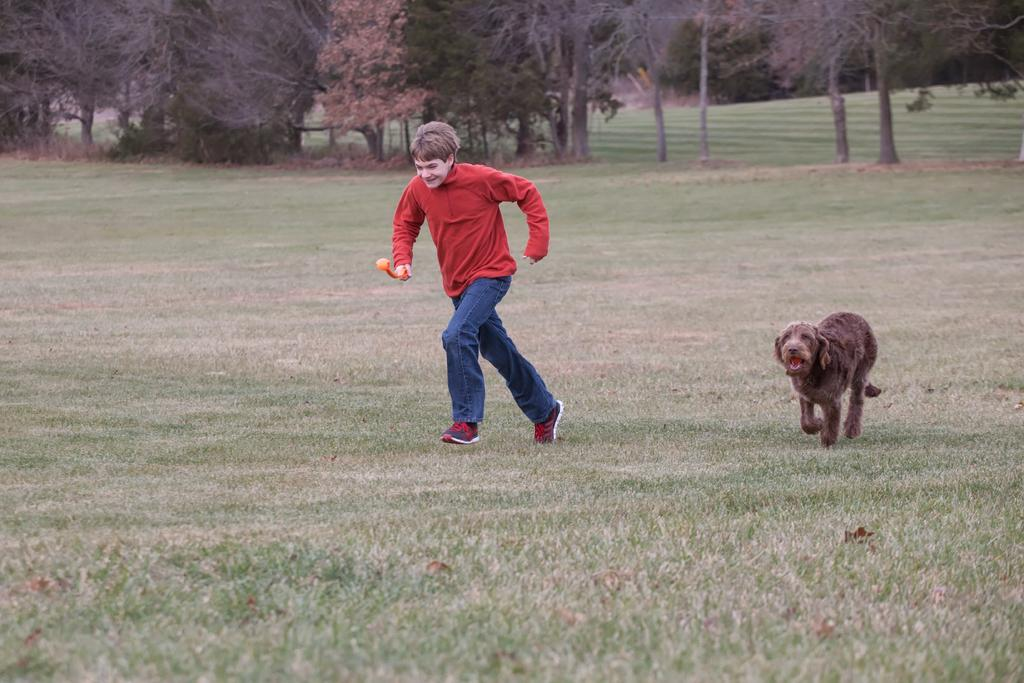What is the person in the image wearing? The person is wearing a red top. What is the person doing in the image? The person is running on the grassland. Is there an animal present in the image? Yes, there is a dog in the image. What is the dog doing in the image? The dog is running on the grassland. What can be seen in the background of the image? There are trees in the background of the image. Where is the shelf located in the image? There is no shelf present in the image. What type of glue is being used by the person in the image? The person in the image is running, not using glue, so it cannot be determined what type of glue might be used. 